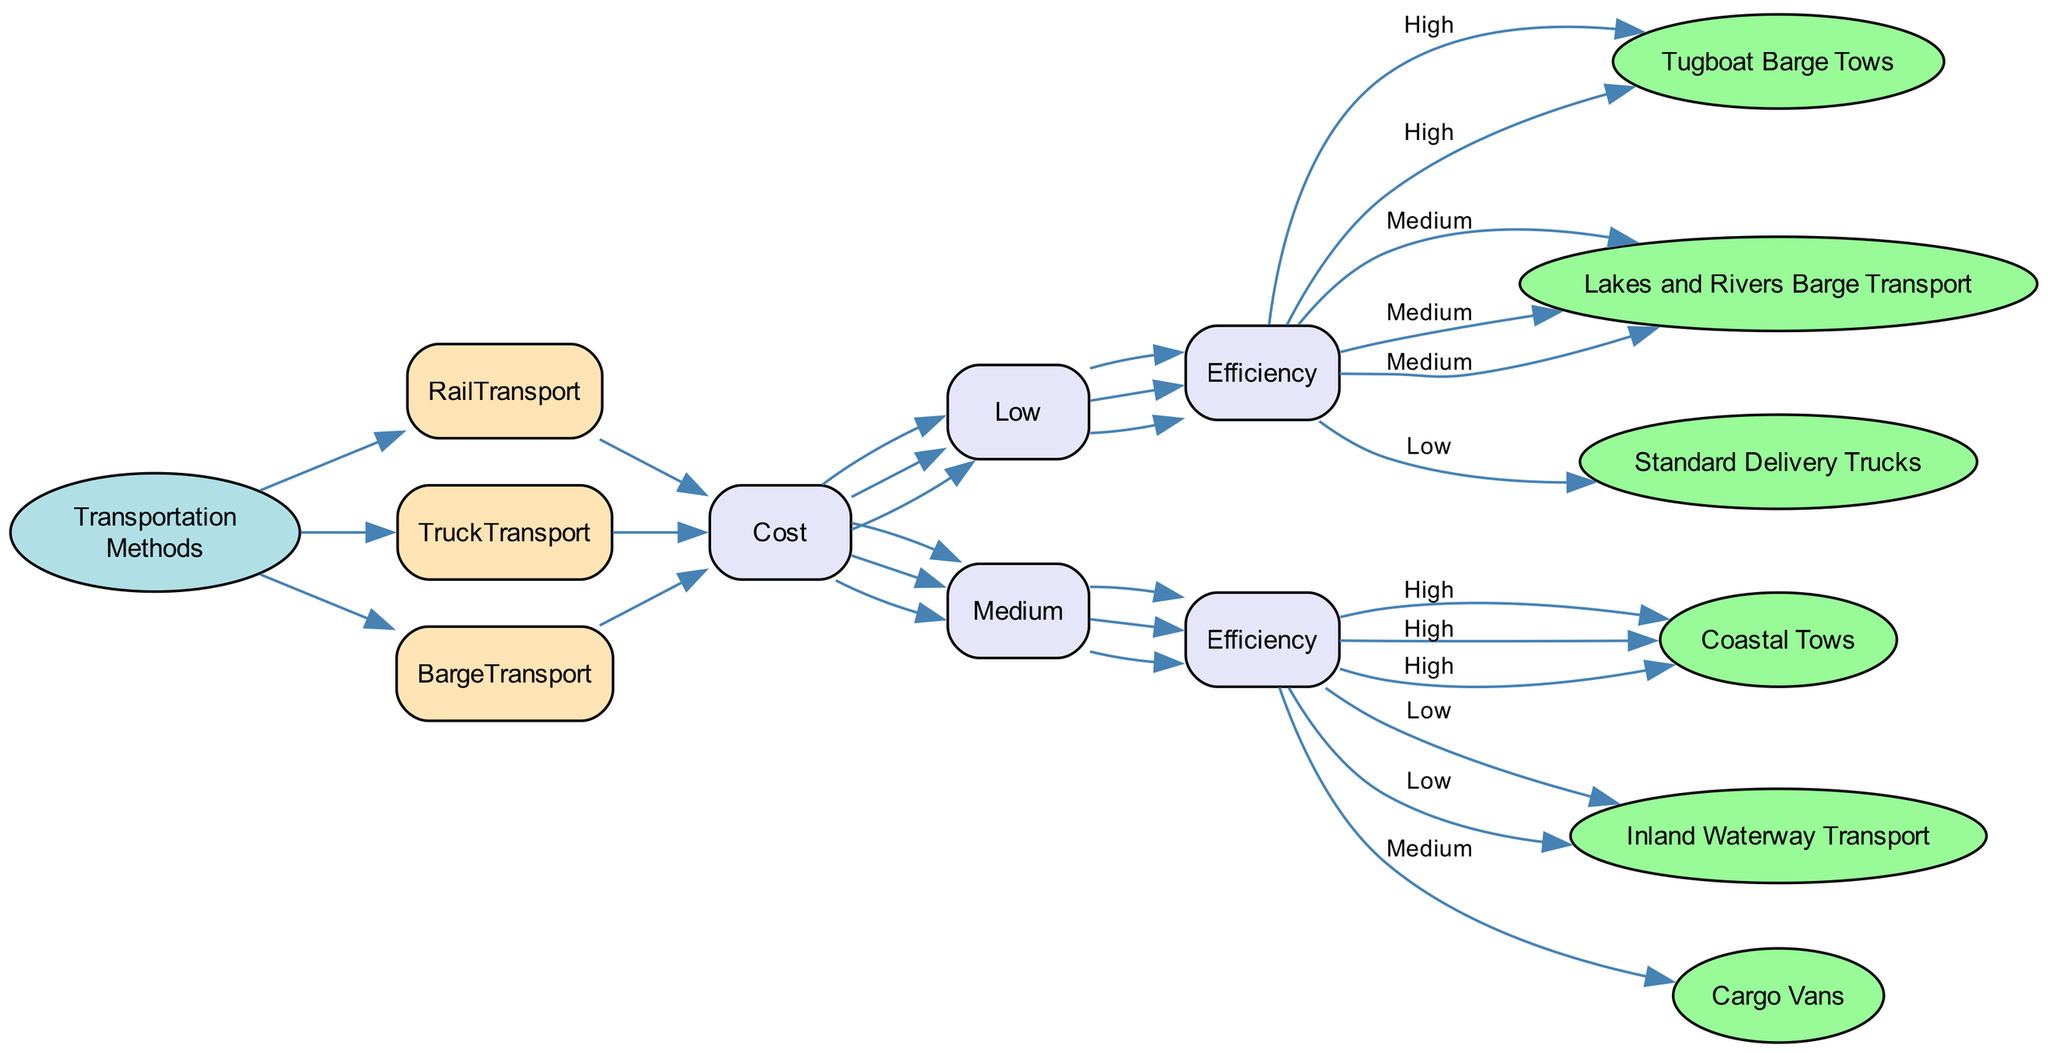What are the three types of transportation methods for corn? The diagram shows three main types of transportation methods branching from the root node: Rail Transport, Truck Transport, and Barge Transport.
Answer: Rail Transport, Truck Transport, Barge Transport Which method has "Refrigerated Trucks" as a delivery option? In the diagram under Truck Transport, when Cost is Medium and Efficiency is High, the delivery option is Refrigerated Trucks.
Answer: Refrigerated Trucks What is the efficiency level for "Mixed Load Trains"? The Mixed Load Trains are listed under Rail Transport where the cost is Medium and efficiency is Low.
Answer: Low How many options are there for Low Cost within Barge Transport? The diagram outlines four options under Barge Transport where Cost is Low: Tugboat Barge Tows and Lakes and Rivers Barge Transport, hence there are two options.
Answer: 2 What would you choose for High Efficiency and Low Cost under Truck Transport? Under Truck Transport, for Low Cost and Efficiency level Low, the option chosen is Standard Delivery Trucks.
Answer: Standard Delivery Trucks Which transportation method is most efficient for Low Cost options? The diagram indicates that the most efficient (High Efficiency) option for Low Cost is Tugboat Barge Tows under Barge Transport.
Answer: Tugboat Barge Tows How many nodes describe options under Medium Cost for Rail Transport? In the Rail Transport section for Medium Cost, there are two efficiency options: Dedicated Freight Trains (High) and Mixed Load Trains (Low), leading to a total of two nodes.
Answer: 2 What type of trucks would you select for Medium Cost and Medium Efficiency? Referring to the Truck Transport section, the option for Medium Cost with Medium Efficiency is Cargo Vans.
Answer: Cargo Vans What is the difference between High Efficiency and Medium Efficiency options for Barge Transport under Low Cost? For Barge Transport under Low Cost, the High Efficiency option is Tugboat Barge Tows, while the Medium Efficiency option is Lakes and Rivers Barge Transport, which are distinct options.
Answer: Tugboat Barge Tows, Lakes and Rivers Barge Transport 